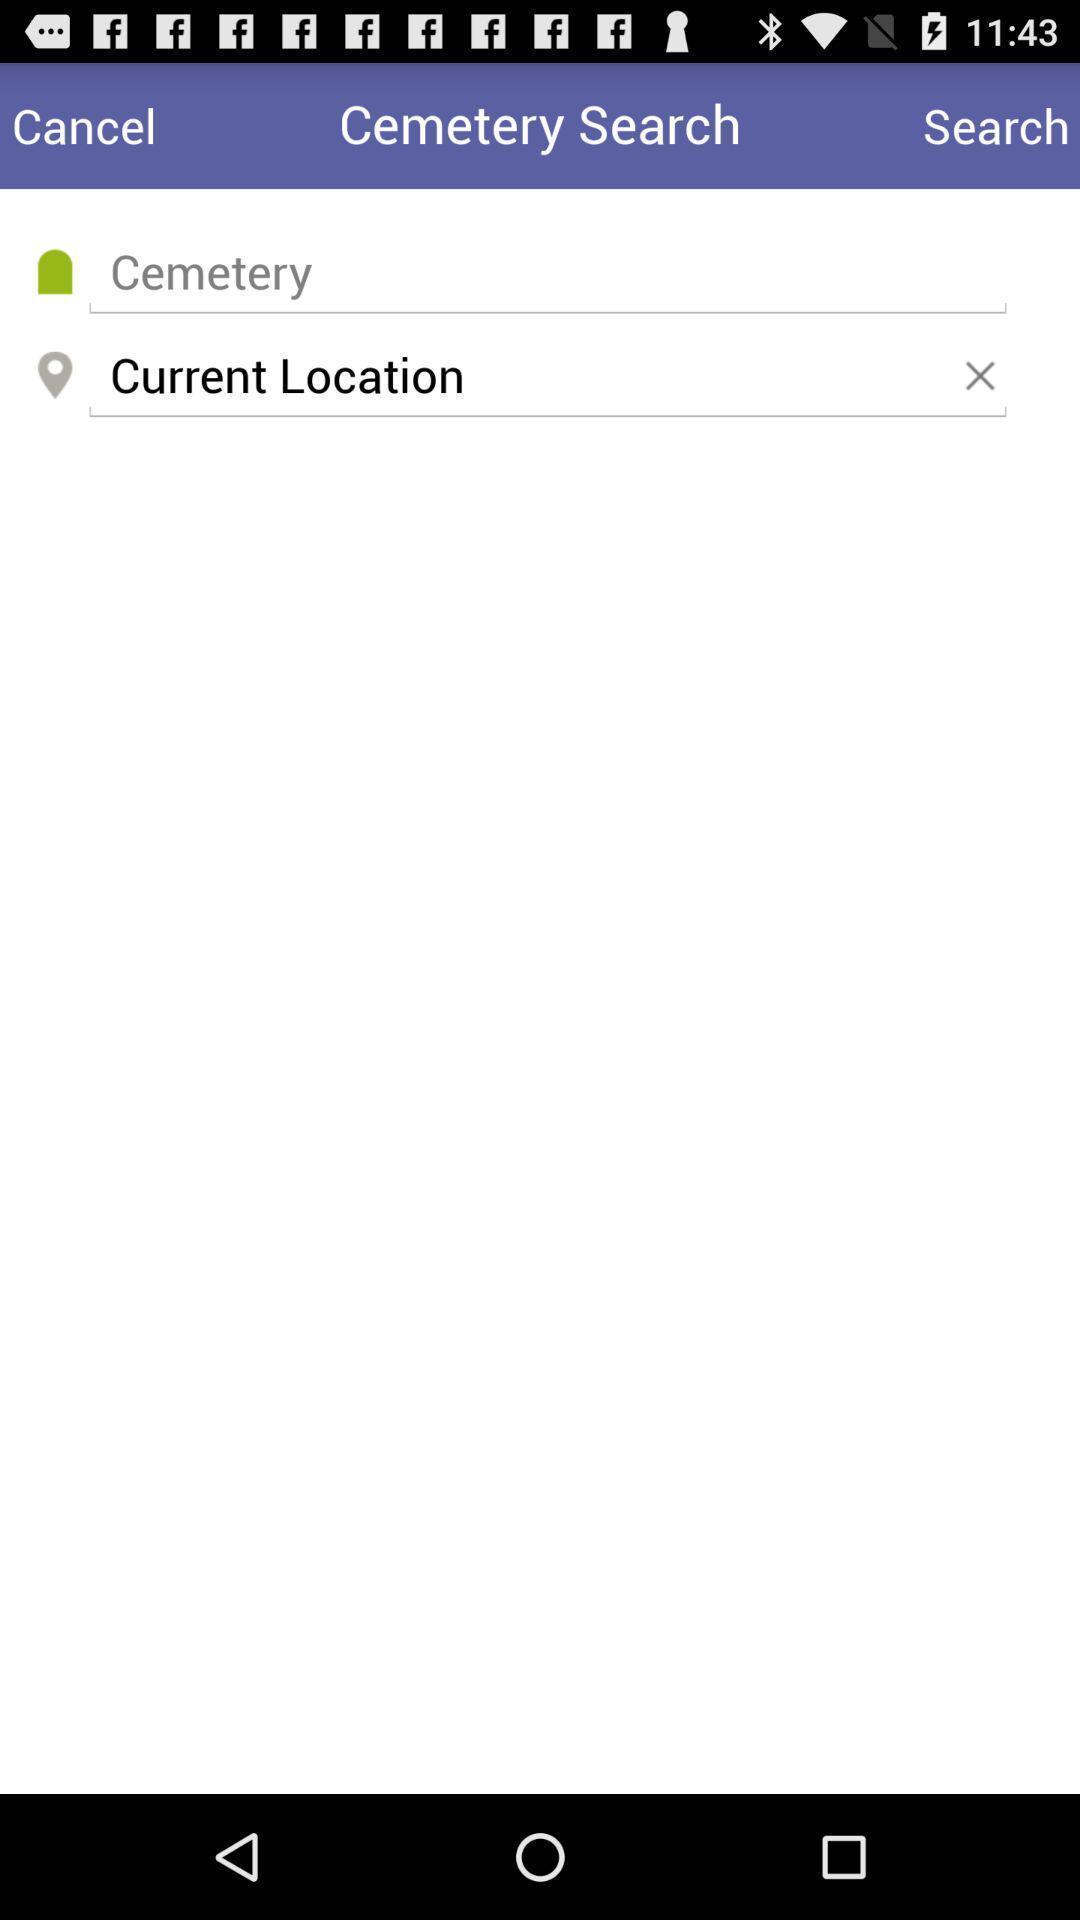What is the overall content of this screenshot? Search page of cemetery searching app. 